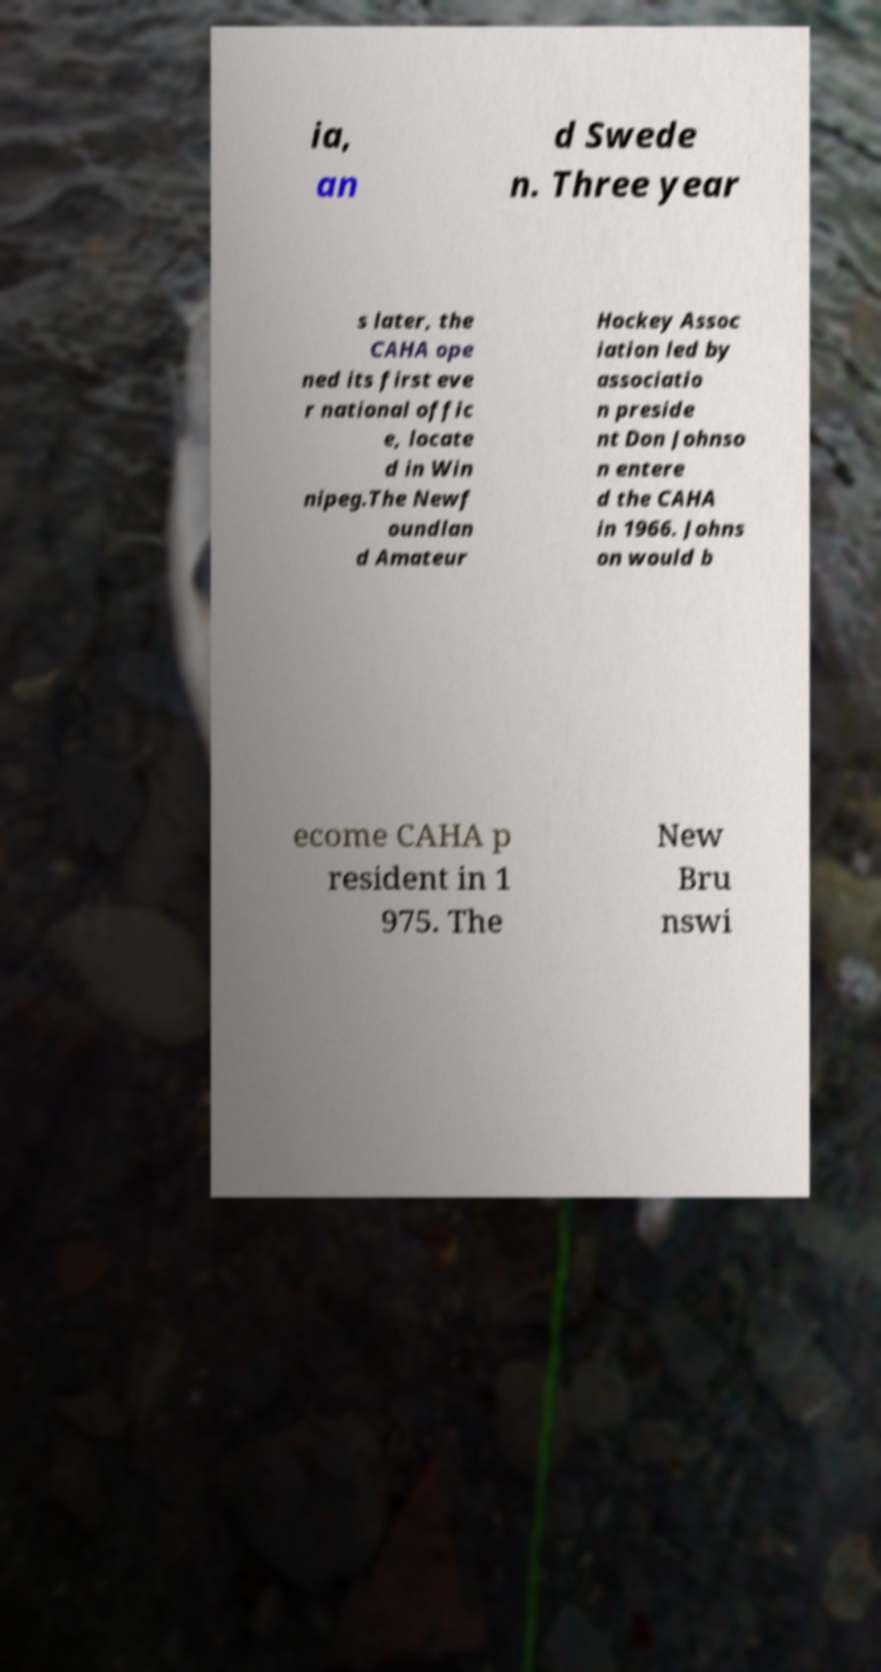Please read and relay the text visible in this image. What does it say? ia, an d Swede n. Three year s later, the CAHA ope ned its first eve r national offic e, locate d in Win nipeg.The Newf oundlan d Amateur Hockey Assoc iation led by associatio n preside nt Don Johnso n entere d the CAHA in 1966. Johns on would b ecome CAHA p resident in 1 975. The New Bru nswi 